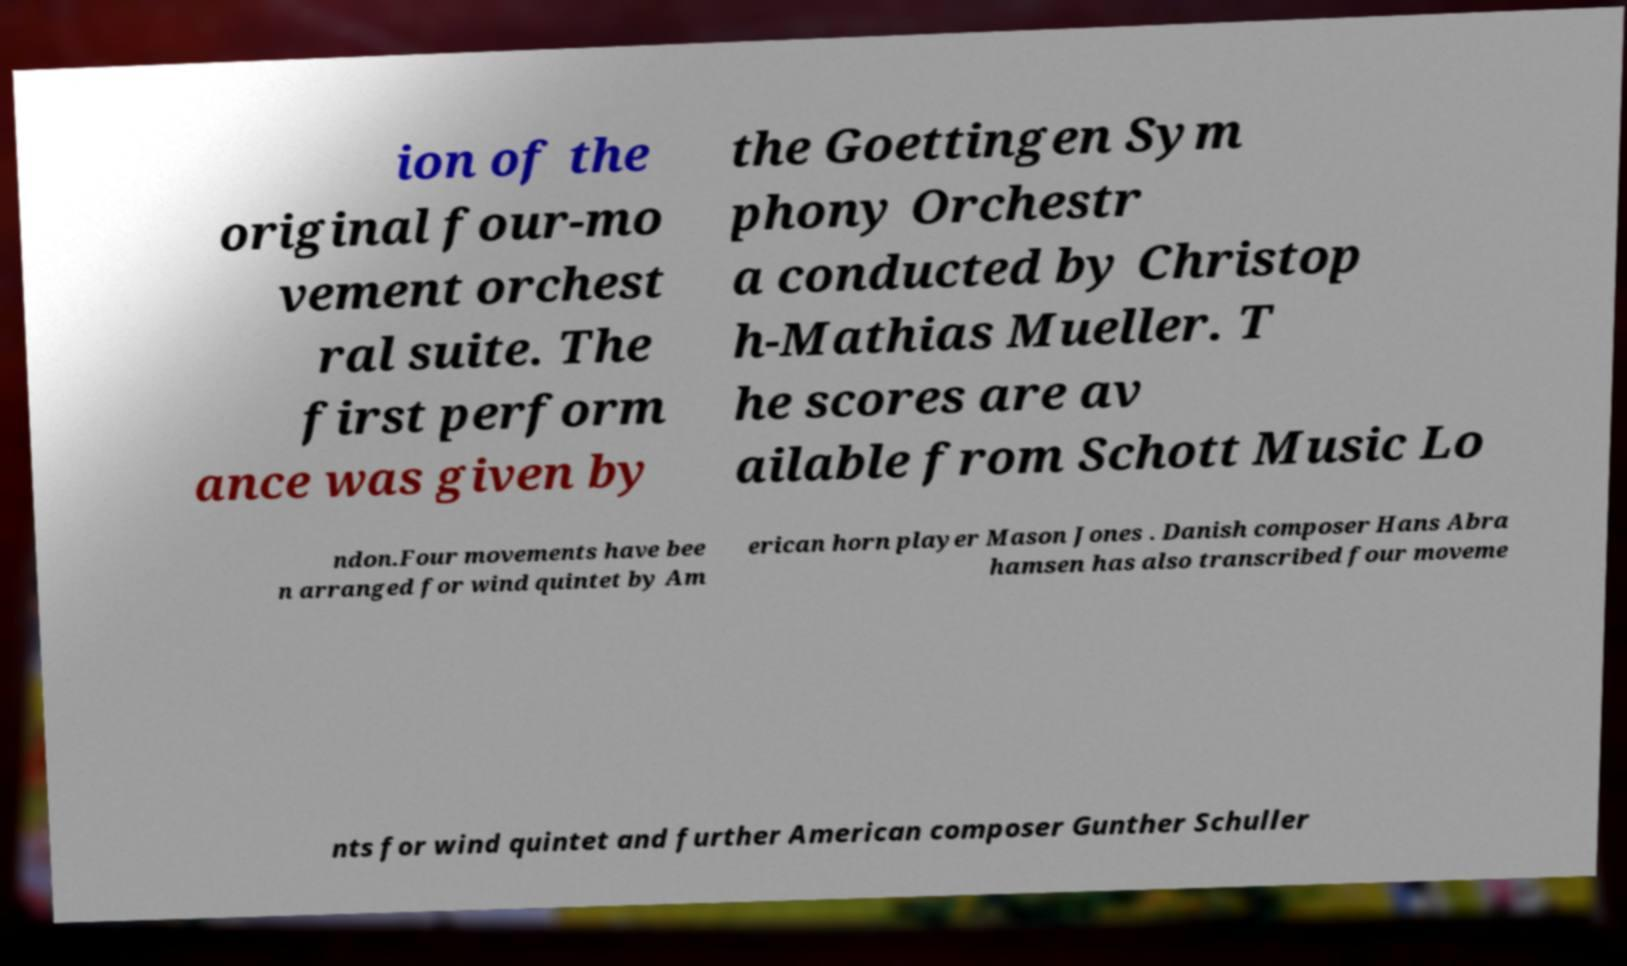For documentation purposes, I need the text within this image transcribed. Could you provide that? ion of the original four-mo vement orchest ral suite. The first perform ance was given by the Goettingen Sym phony Orchestr a conducted by Christop h-Mathias Mueller. T he scores are av ailable from Schott Music Lo ndon.Four movements have bee n arranged for wind quintet by Am erican horn player Mason Jones . Danish composer Hans Abra hamsen has also transcribed four moveme nts for wind quintet and further American composer Gunther Schuller 